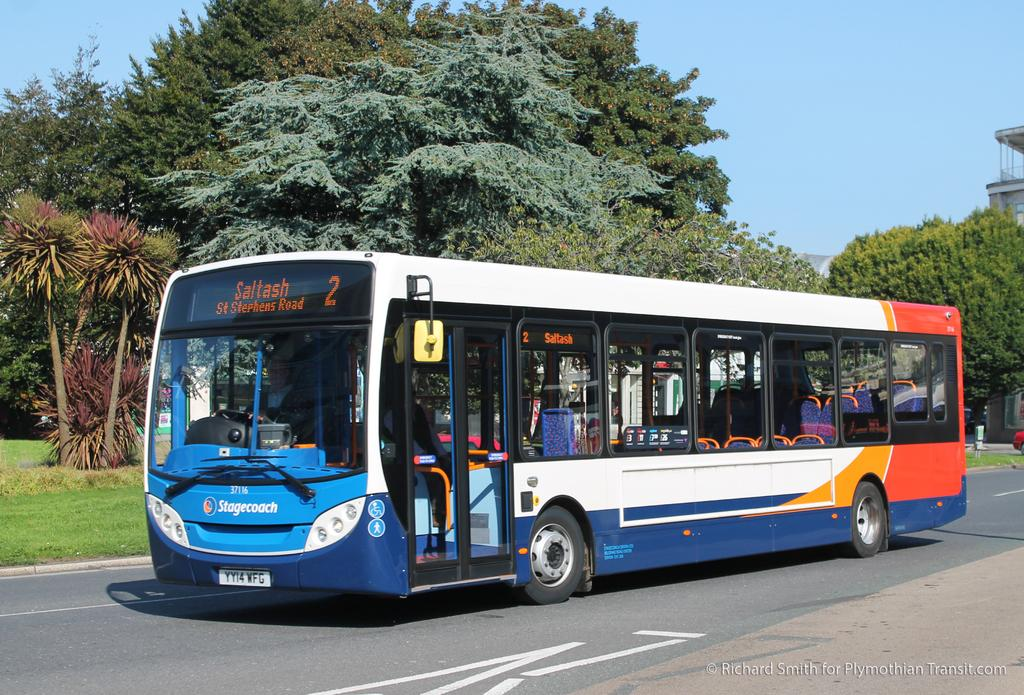What is the main subject in the center of the image? There is a bus in the center of the image. What is the bus doing in the image? The bus is moving on the road. What can be seen in the background of the image? There are trees and a building in the background of the image. What type of vegetation is on the right side of the image? There is grass on the ground on the right side of the image. What type of bead is hanging from the door of the building in the image? There is no bead hanging from the door of the building in the image. What songs can be heard playing from the bus in the image? There is no indication of any songs being played in the image; it only shows a bus moving on the road. 